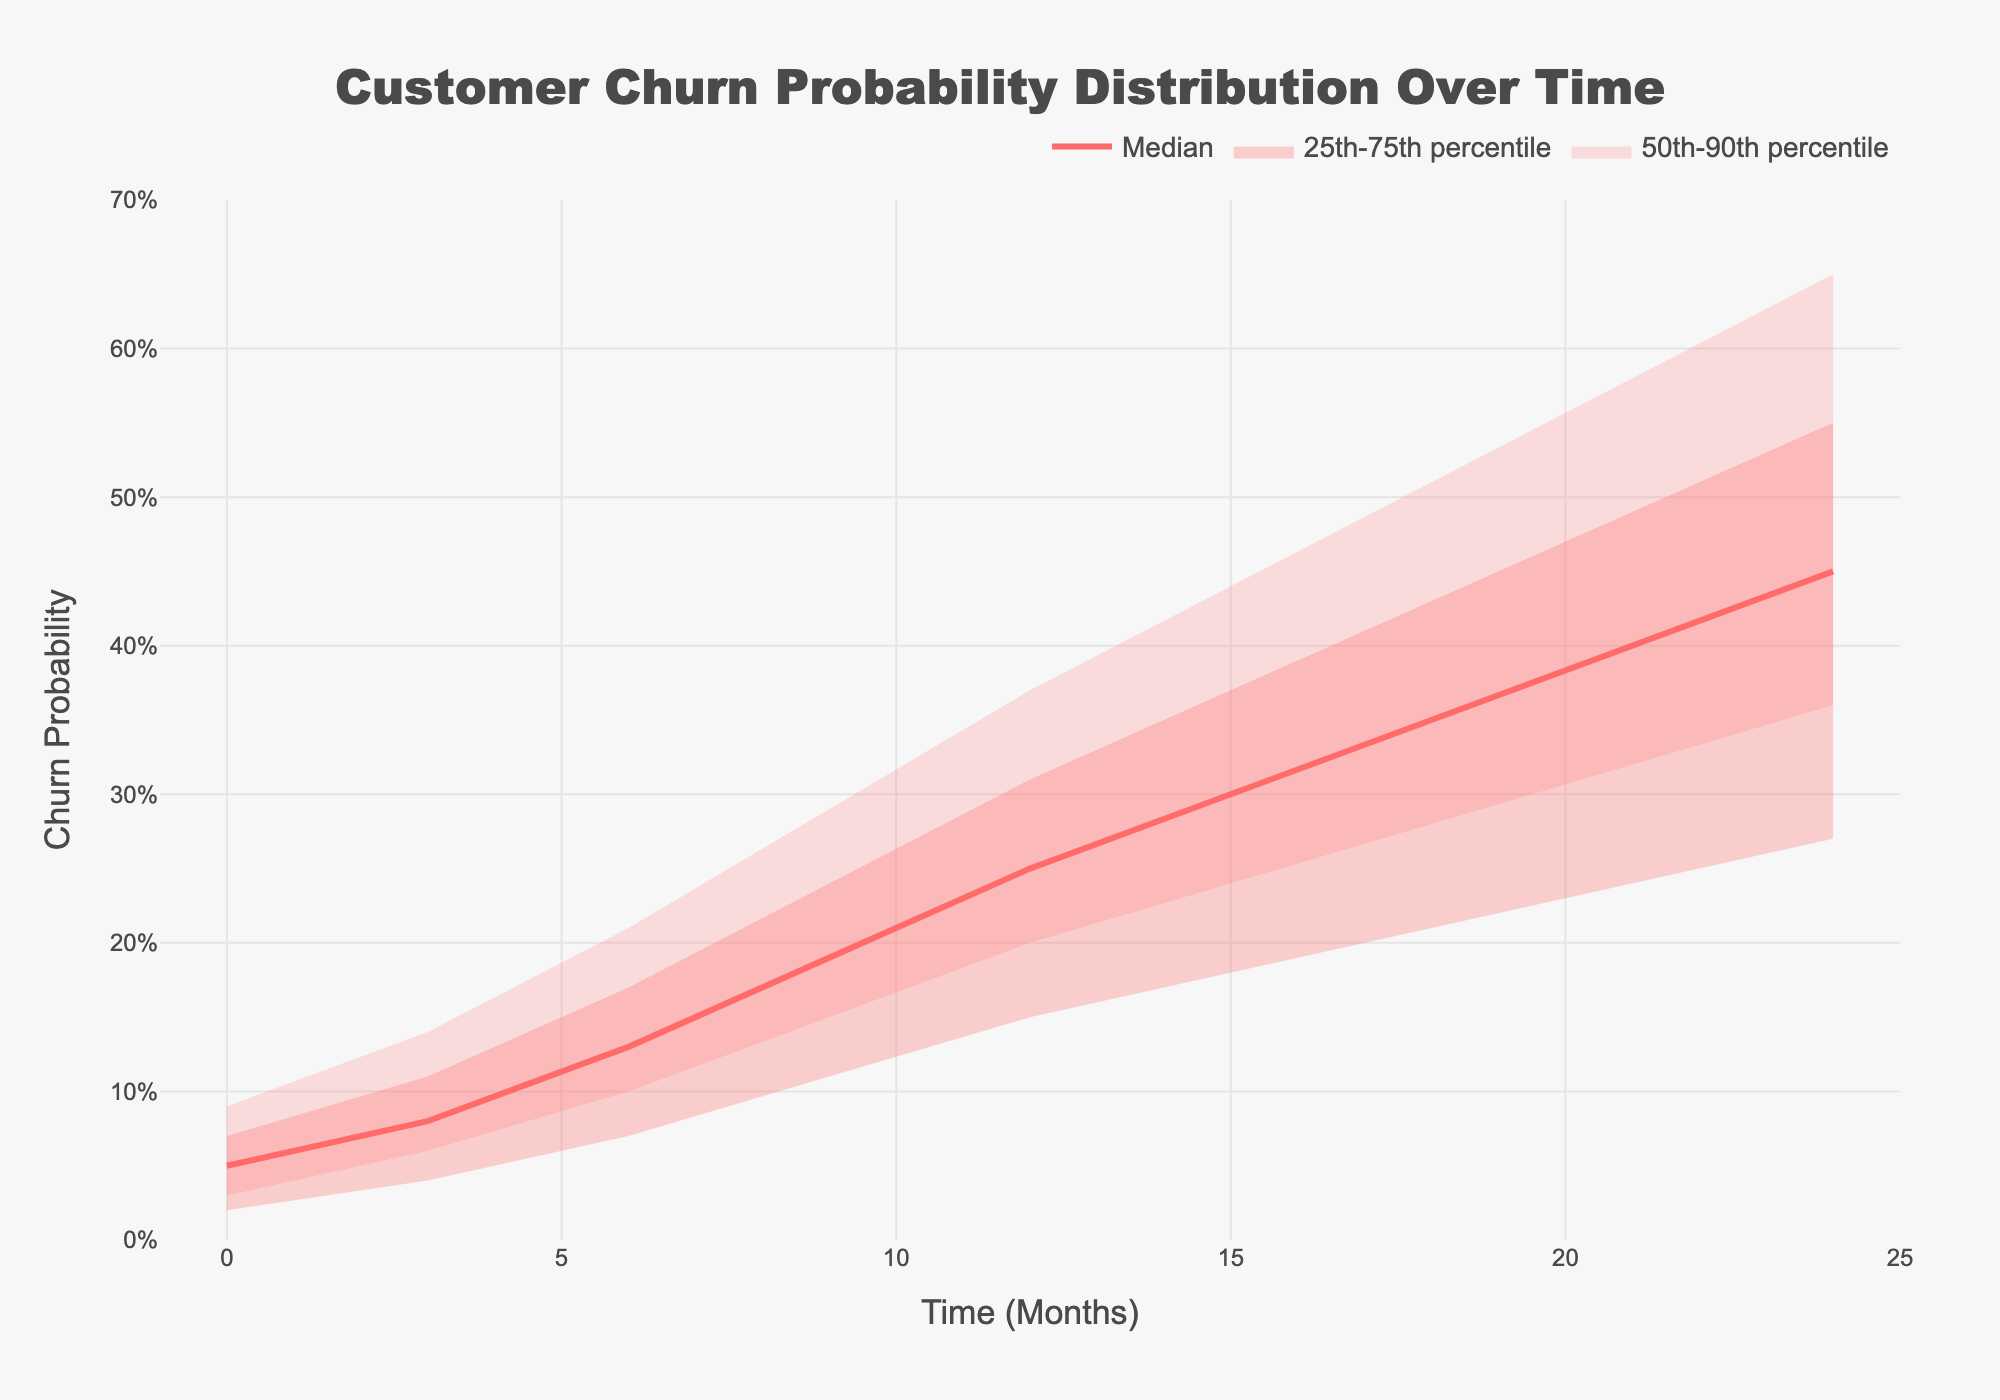What is the title of the chart? The title of the chart is located at the top and is written in larger and bolder font compared to the rest of the text. The title states "Customer Churn Probability Distribution Over Time".
Answer: Customer Churn Probability Distribution Over Time What are the y-axis and x-axis labels? The axis labels are found along each axis. The y-axis label is "Churn Probability" and the x-axis label is "Time (Months)".
Answer: Churn Probability; Time (Months) How does the median churn probability change from month 0 to month 24? To determine the change, look at the median line (P50) on the chart from the starting point to the end point. At month 0, the median churn probability starts at 0.05 and increases steadily to 0.45 by month 24.
Answer: Increases from 0.05 to 0.45 What is the range of the churn probability at month 12? To find the range, check the values from the 10th percentile (P10) to the 90th percentile (P90) at month 12. The churn probability ranges from 0.15 to 0.37.
Answer: 0.15 to 0.37 Which month shows the greatest increase in the median churn probability? Look at the increments between each plotted point of the median (P50). The largest increase occurs between month 0 and month 3, where the median churn probability jumps from 0.05 to 0.08.
Answer: Between month 0 and month 3 At month 18, is the probability more likely to be closer to the 25th percentile or the 75th percentile? Look at the spread of values around month 18 and compare the distances. The 25th percentile is at 0.28 and the 75th percentile is at 0.43, while the median is at 0.35.
Answer: Closer to the 25th percentile How does the range of churn probabilities change over time? By examining the width of the fan chart bands over time, notice how the fan widens as time progresses. This indicates that the range between the 10th and 90th percentiles increases, showing greater uncertainty in churn probability as time goes on.
Answer: Increases over time What is the churn probability range for the interquartile range (IQR) at month 9? The interquartile range is between the 25th percentile (P25) and the 75th percentile (P75). At month 9, P25 is 0.15 and P75 is 0.24.
Answer: 0.15 to 0.24 